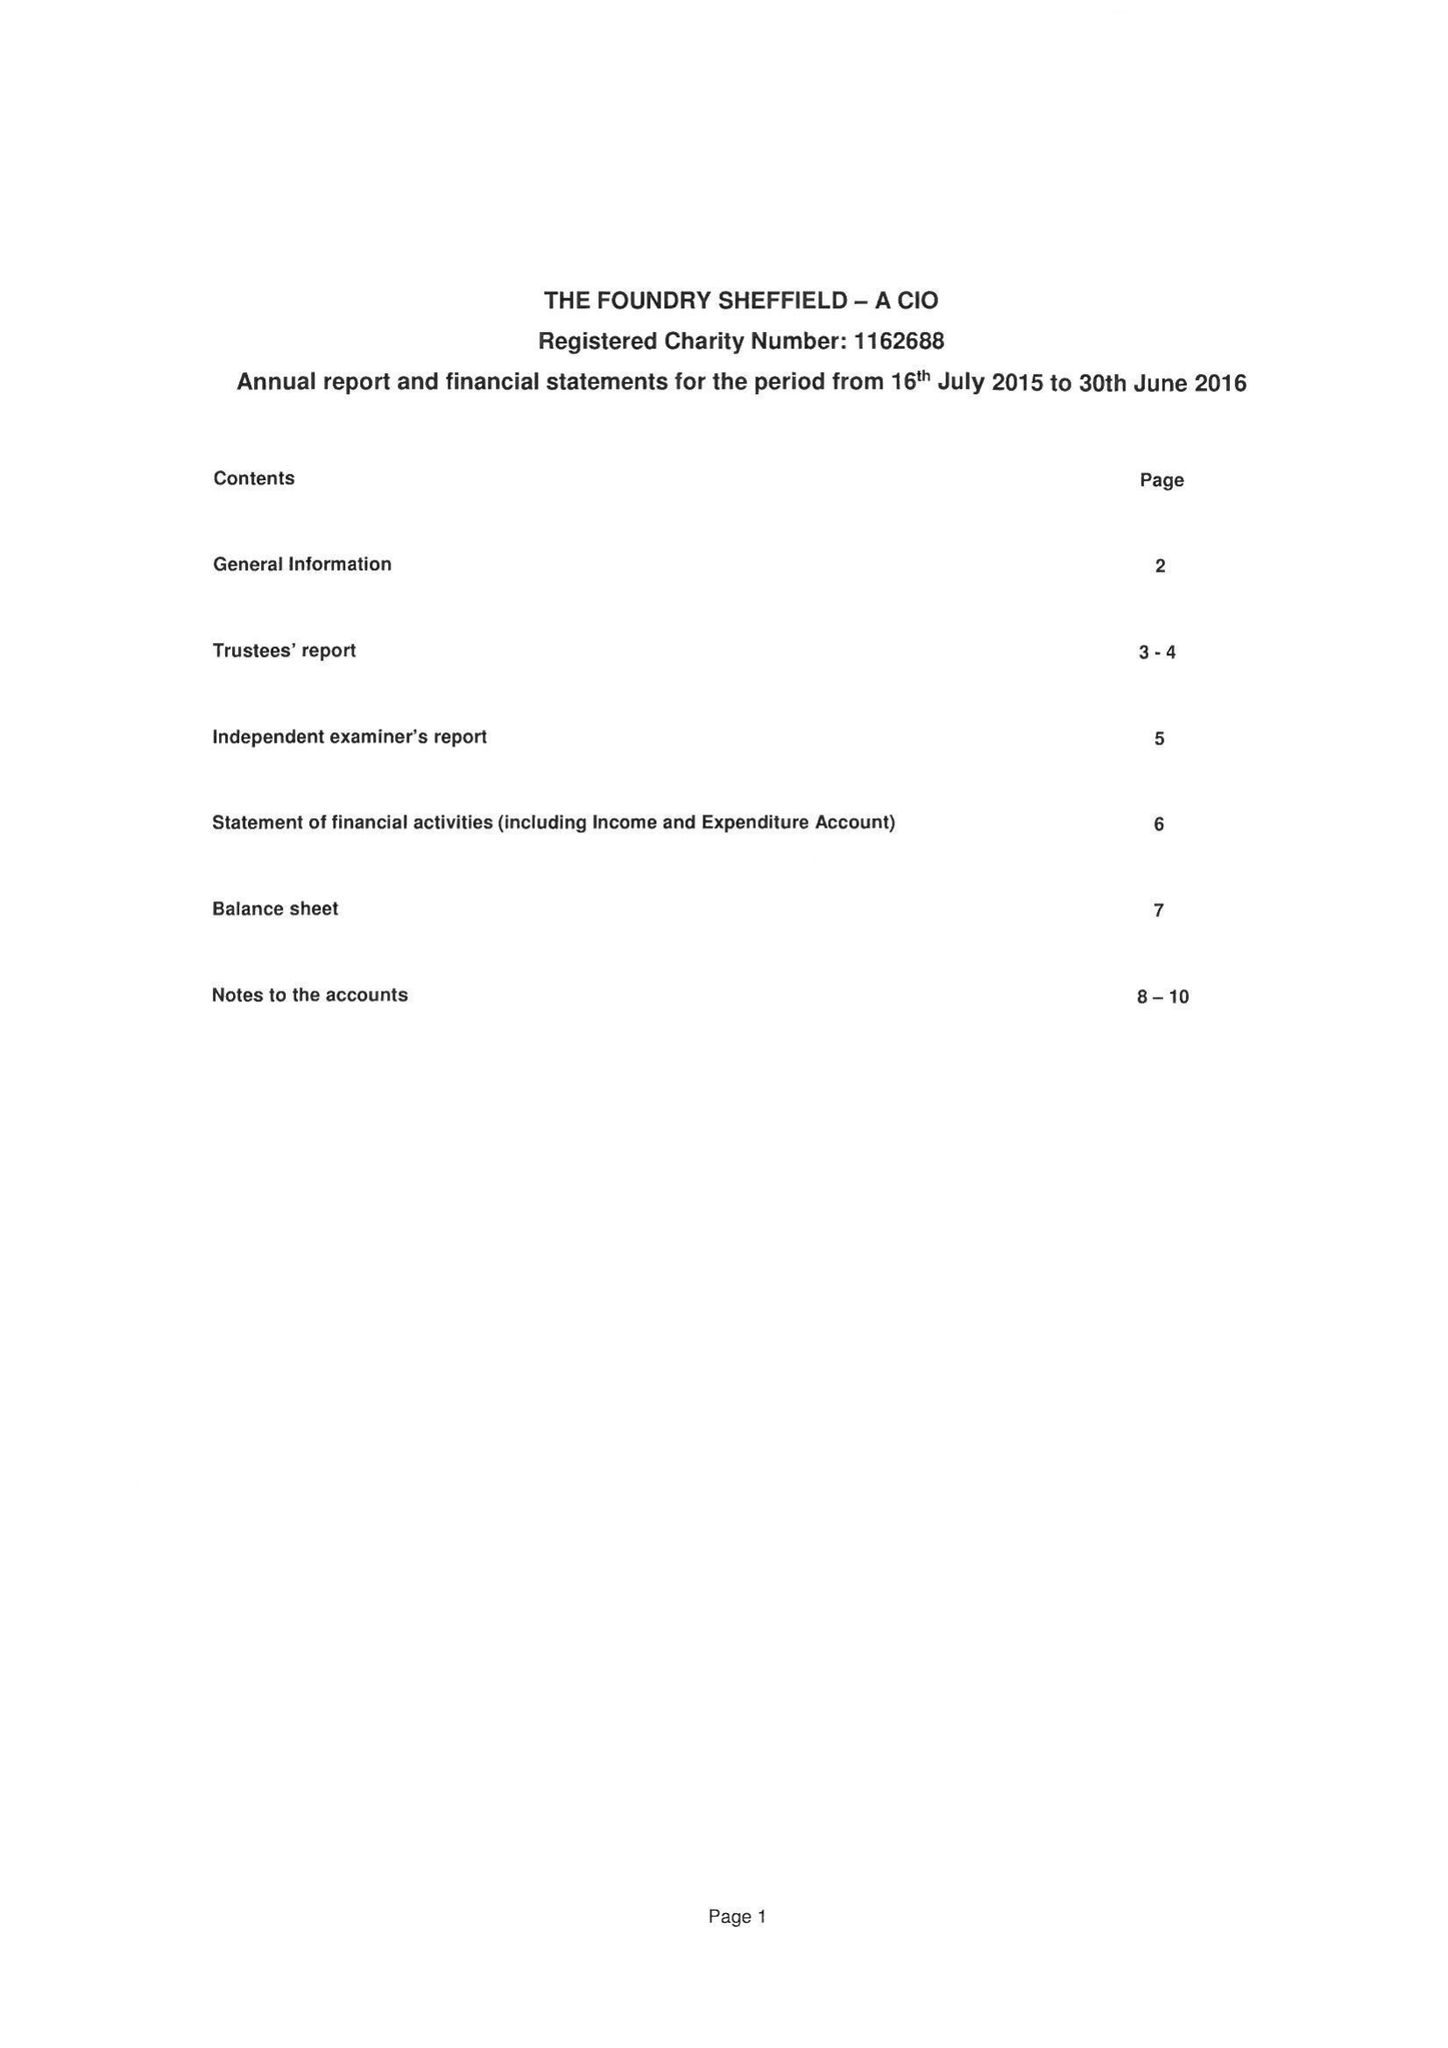What is the value for the spending_annually_in_british_pounds?
Answer the question using a single word or phrase. 33499.00 